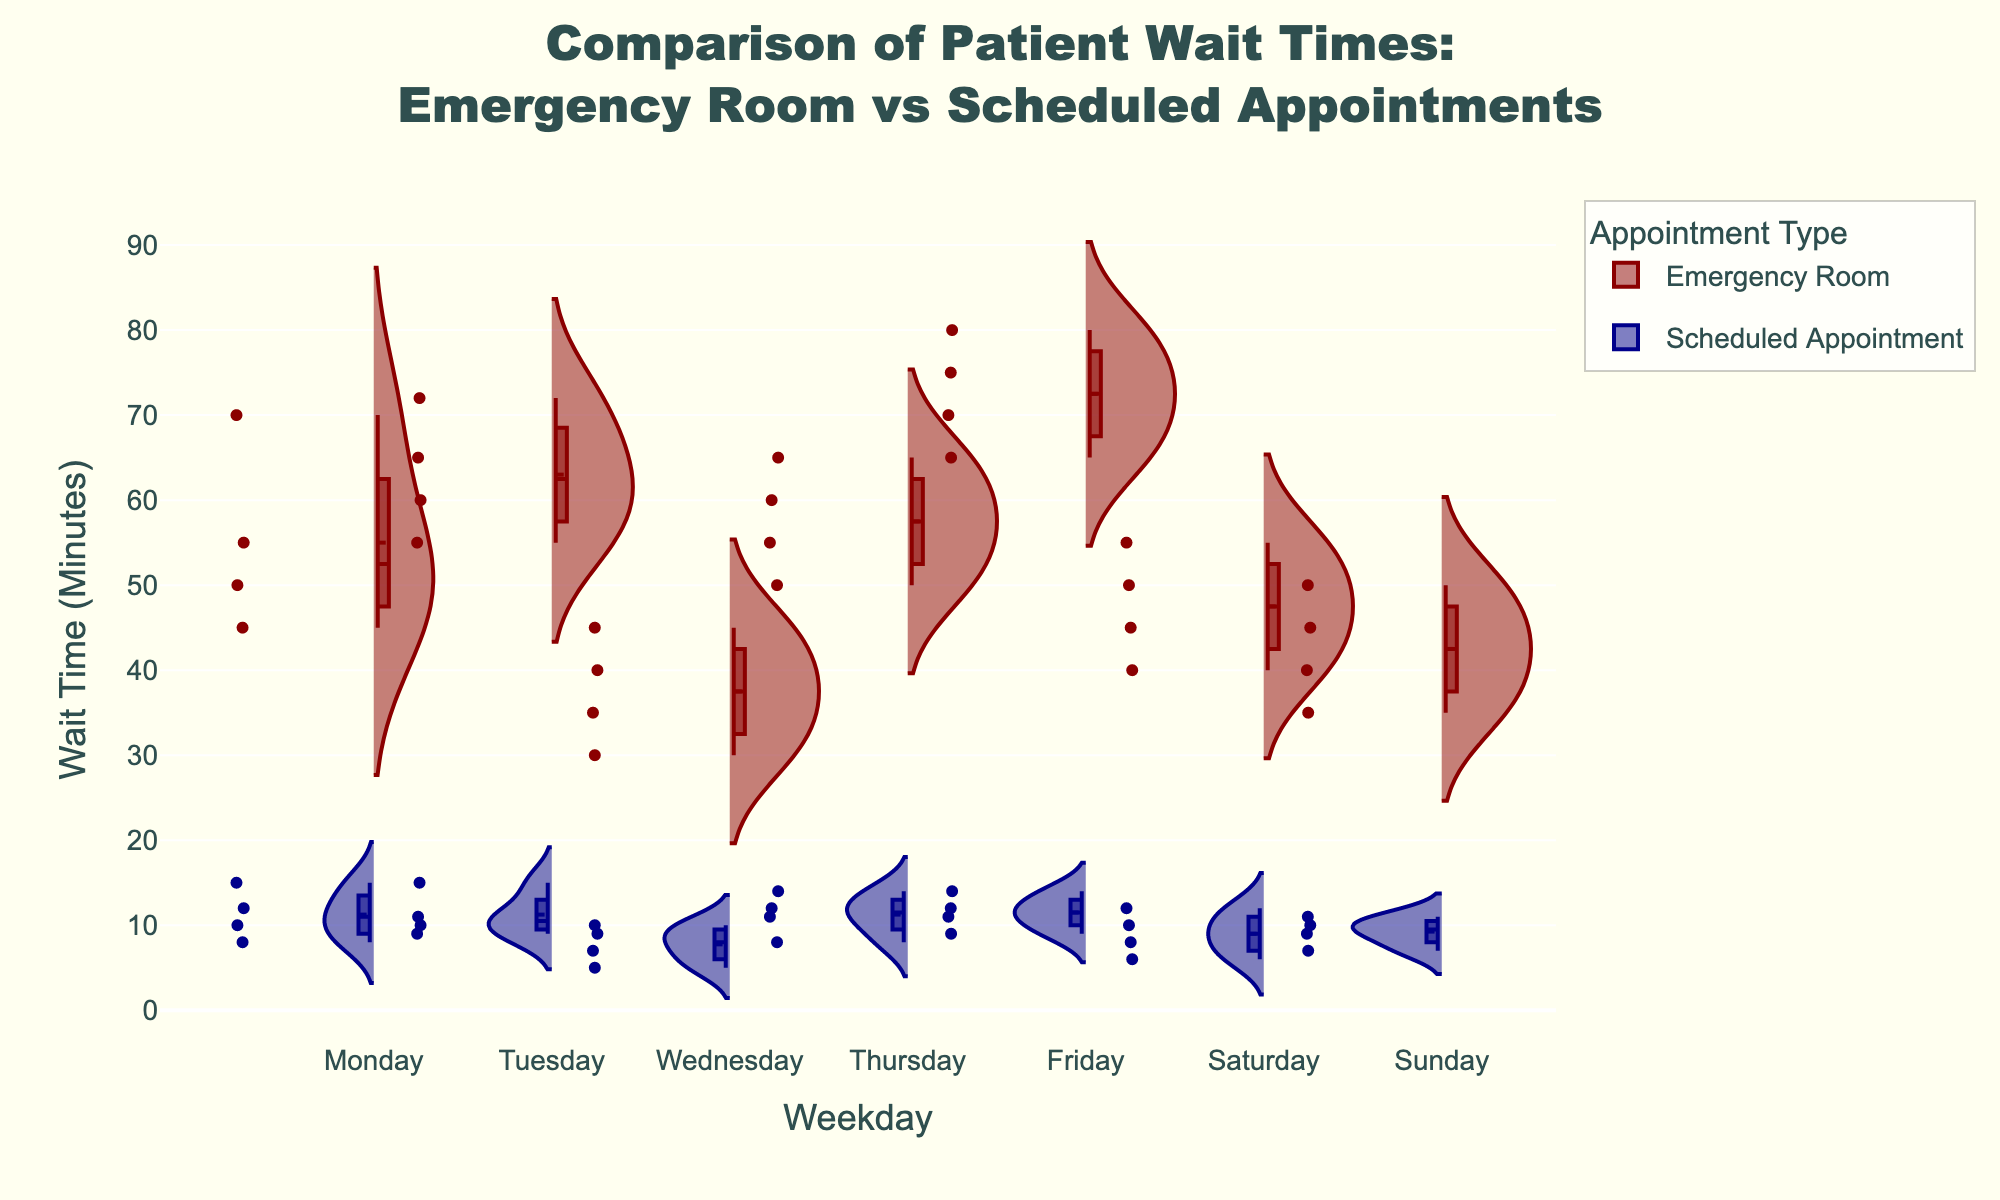What is the average wait time for emergency room visits on Friday? Look at the wait times for emergency room visits on Friday (70, 75, 80, 65). Add these values to get a total of 290, then divide by the number of data points (4) to get the average.
Answer: 72.5 minutes Which day has the lowest median wait time for scheduled appointments? Look at the violin plot for scheduled appointments across all weekdays. The median is the central line. Saturday has the lowest median wait time.
Answer: Saturday Are there more wait time data points for emergency room visits or scheduled appointments on Monday? Compare the number of points plotted for Monday in both the emergency room and scheduled appointment sections of the plot. There are more points for emergency room visits.
Answer: Emergency Room Is the distribution of wait times for scheduled appointments wider or narrower than for emergency room visits on Thursday? Compare the spread of the violin plots. The scheduled appointments have a narrower distribution, indicating less variability in wait times.
Answer: Narrower What is the range of wait times for emergency room visits on Wednesday? Look at the highest and lowest points of the violin plot for Wednesday's emergency room visits. The range is the difference between the highest and lowest values, which are 30 and 45.
Answer: 15 minutes Which appointment type generally has lower wait times? Compare the general position and spread of the violin plots for both appointment types across all days. Scheduled appointments generally have lower wait times.
Answer: Scheduled Appointments Is there a day where the wait times for scheduled appointments are longer than for emergency room visits? Compare the positions of the violin plots for each weekday. No day shows scheduled appointments having longer wait times.
Answer: No Which day has the highest maximum wait time for scheduled appointments? Look at the top of the violin plots for scheduled appointments across all weekdays. Friday has the highest maximum wait time.
Answer: Friday Do weekend days show similar wait times for emergency room visits? Compare the weekend violin plots for emergency room visits. Both Saturday and Sunday have similar spread and medians.
Answer: Yes On which day is there the smallest gap between the median wait times of emergency room visits and scheduled appointments? Compare the median lines of the violin plots for each weekday. Wednesday shows the smallest gap between the two medians.
Answer: Wednesday 